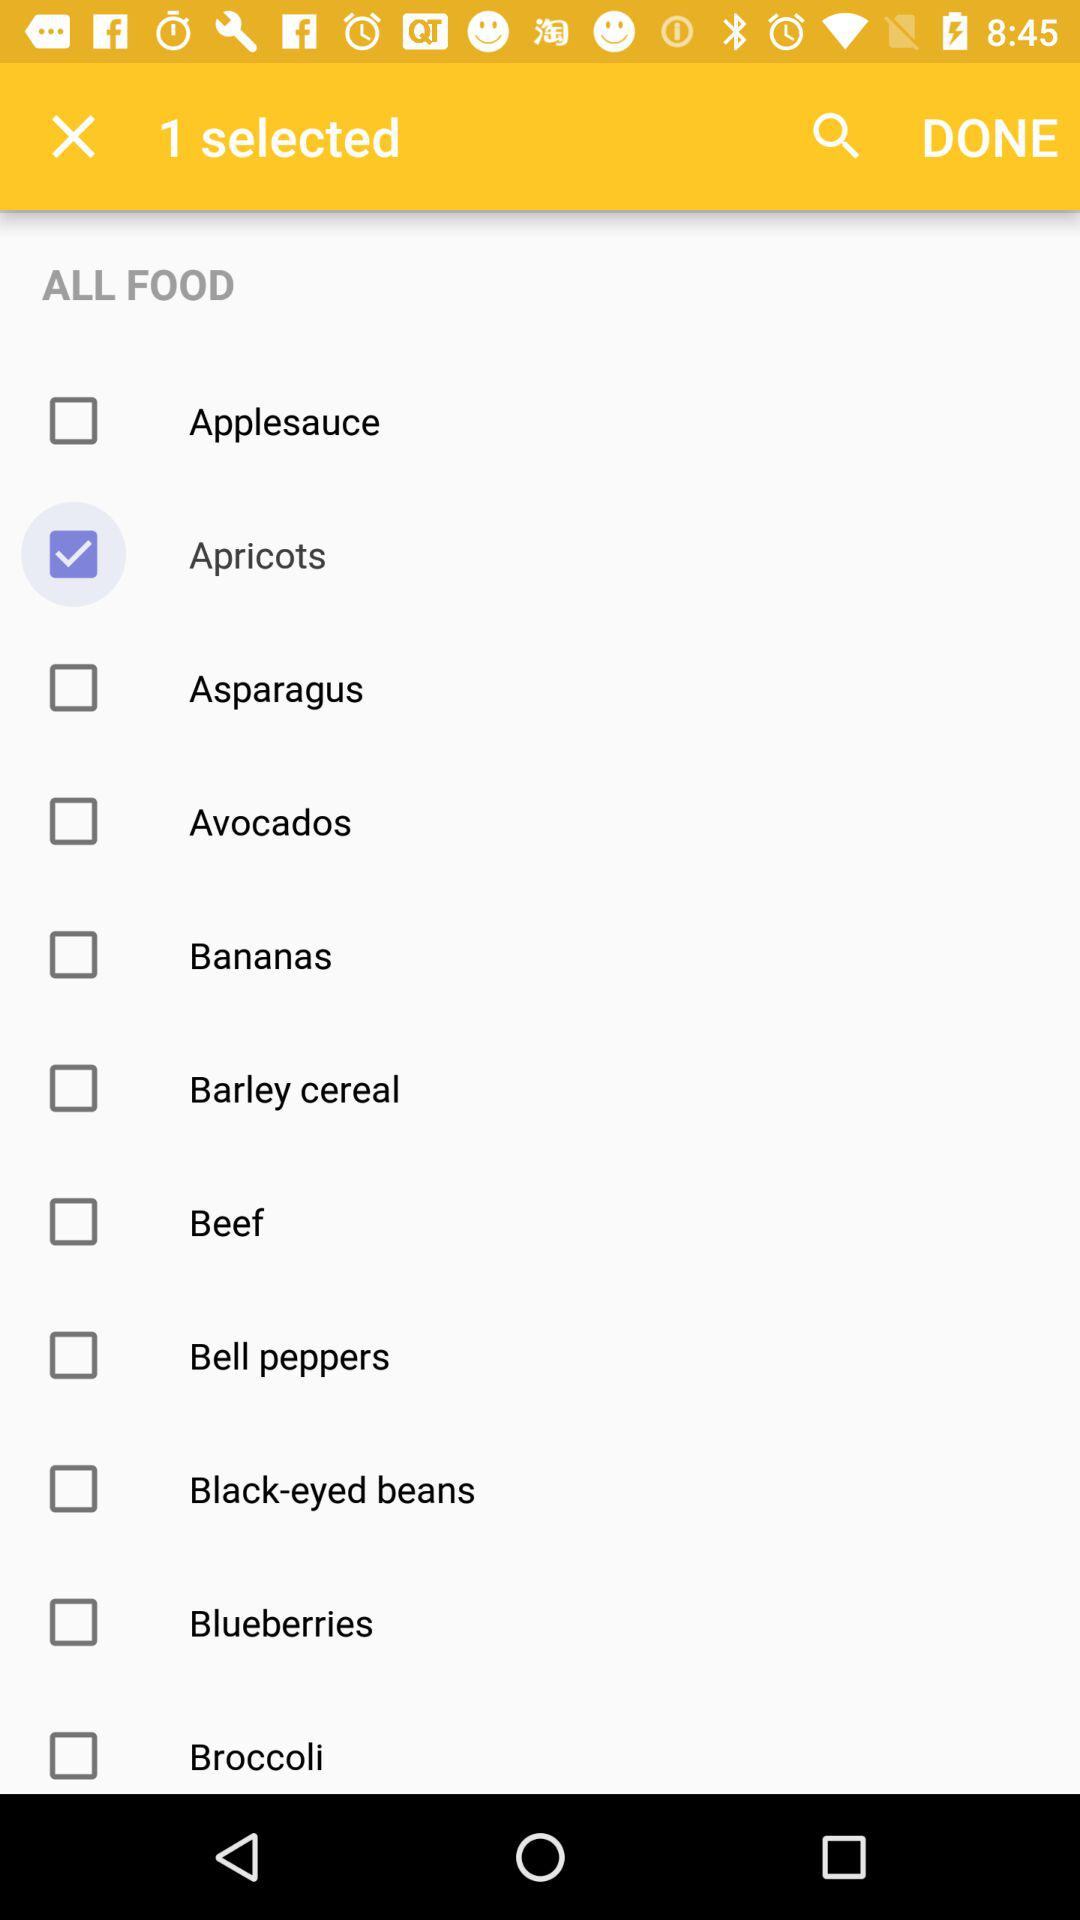Which option is selected? The selected option is "Apricots". 